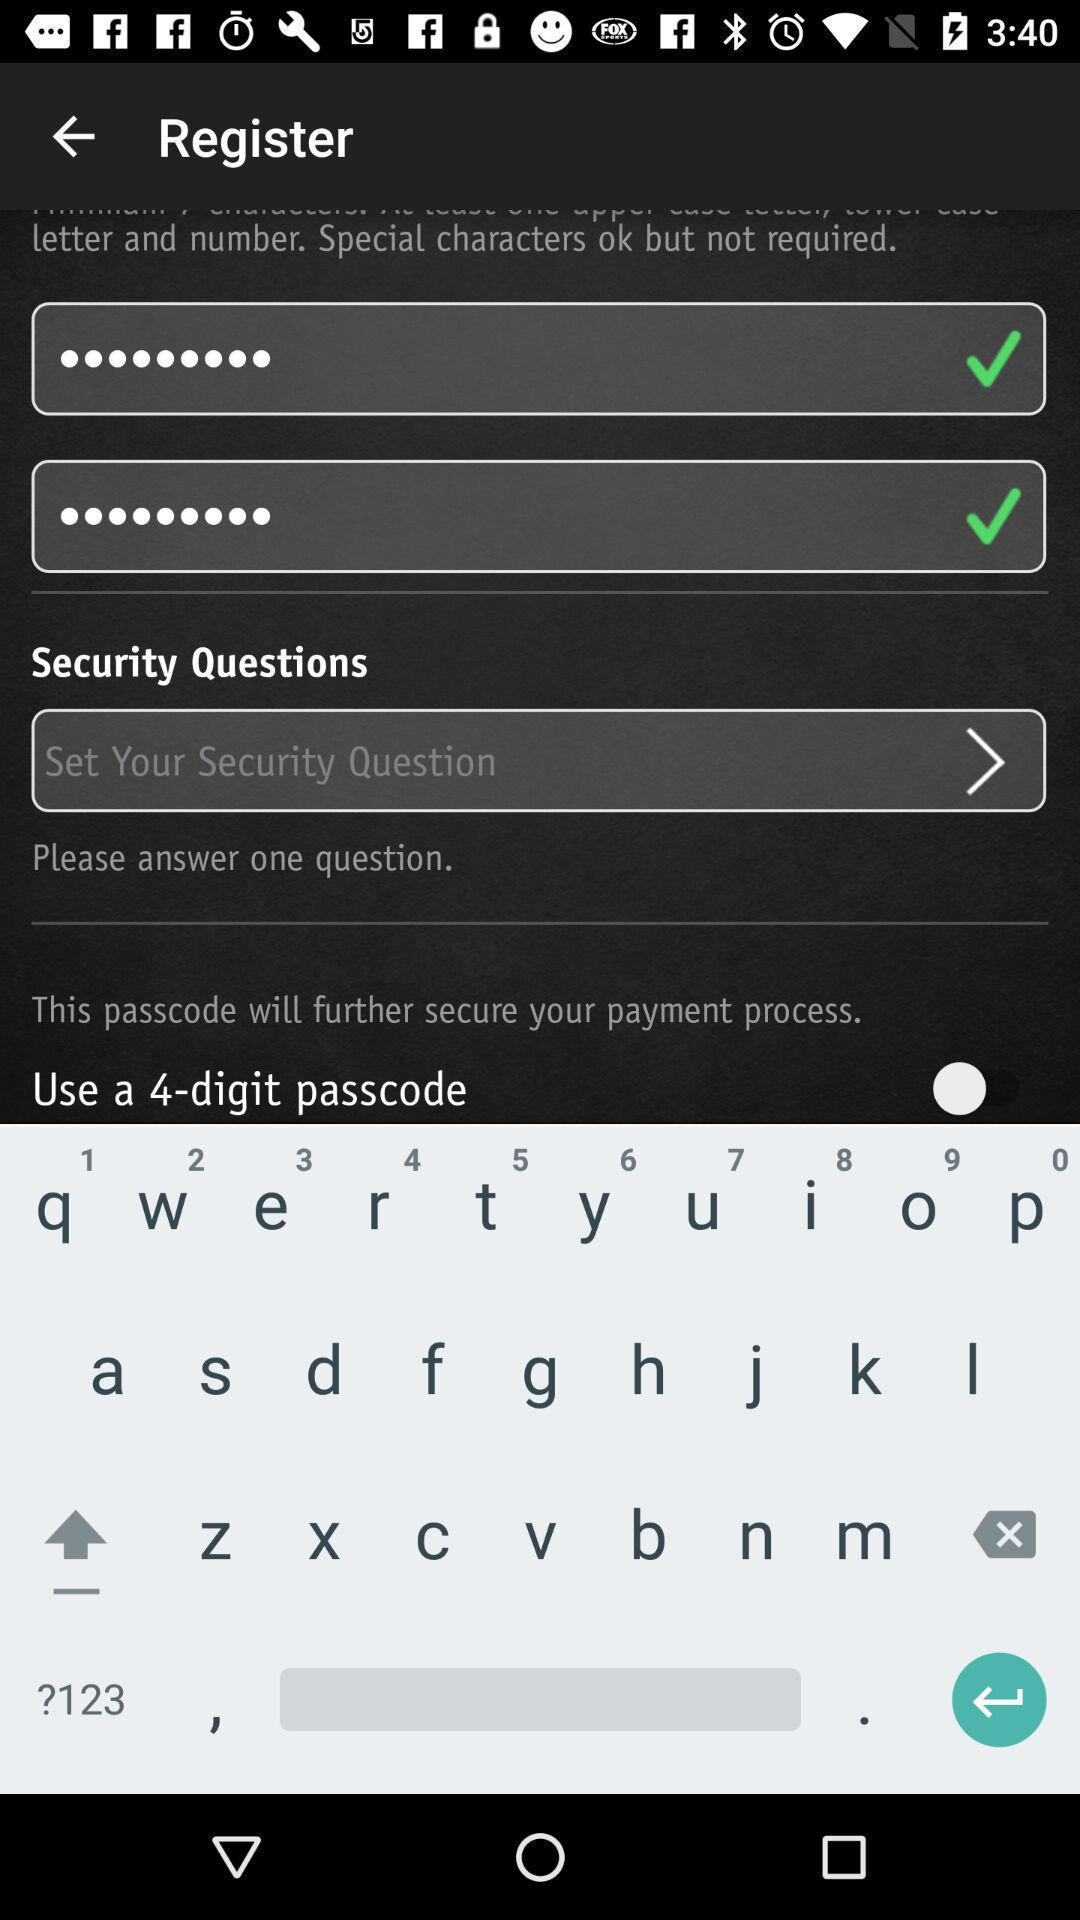How many digits for the passcode are required? There are 4 digits required for the passcode. 